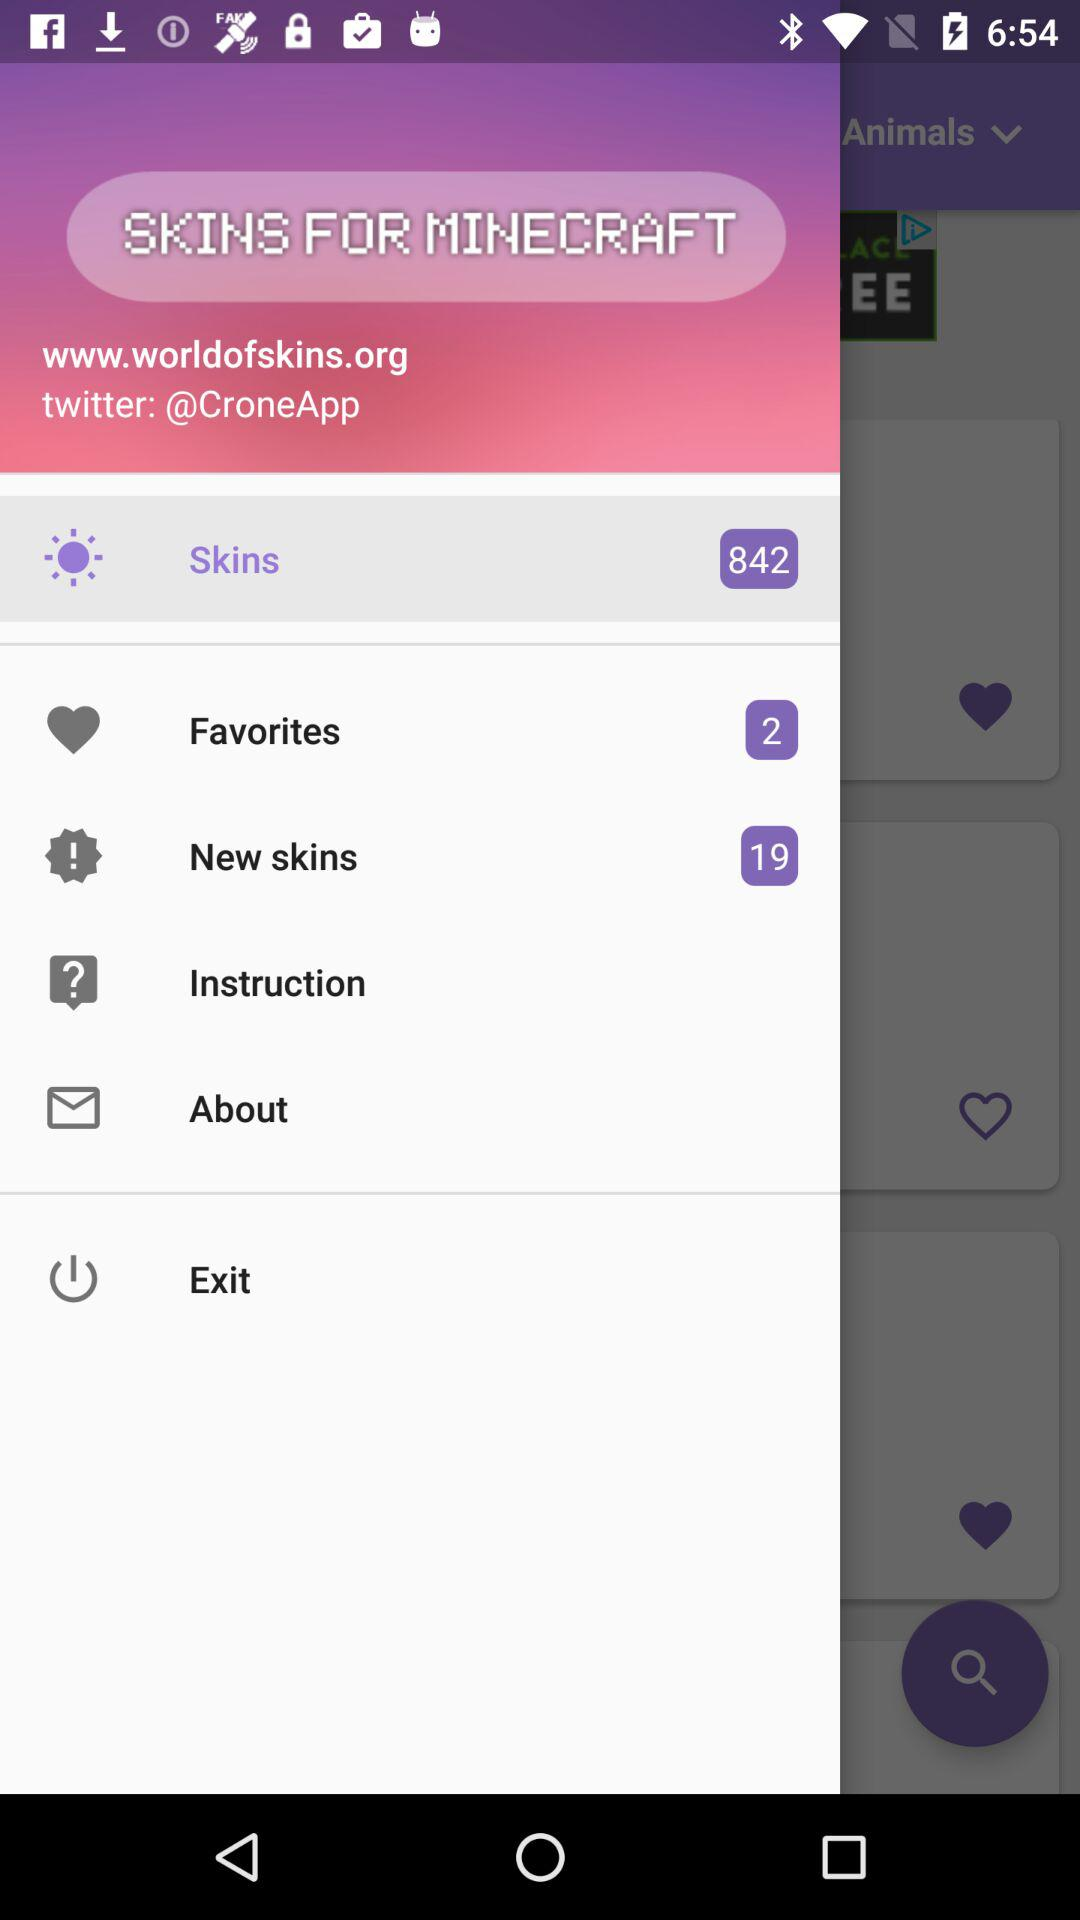How many items are there in "New skins"? There are 19 items in "New skins". 